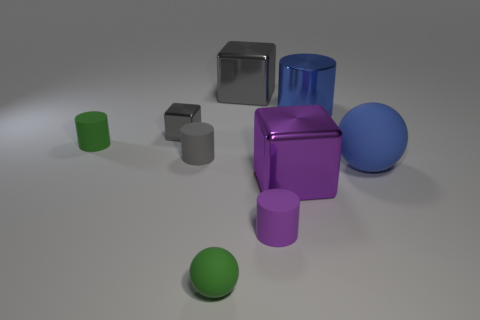Subtract all large blocks. How many blocks are left? 1 Subtract all gray cylinders. How many cylinders are left? 3 Subtract all cubes. How many objects are left? 6 Add 8 tiny green matte balls. How many tiny green matte balls are left? 9 Add 6 tiny purple cylinders. How many tiny purple cylinders exist? 7 Subtract 1 gray cylinders. How many objects are left? 8 Subtract 2 cylinders. How many cylinders are left? 2 Subtract all yellow spheres. Subtract all blue cylinders. How many spheres are left? 2 Subtract all red balls. How many gray cubes are left? 2 Subtract all gray cylinders. Subtract all big purple things. How many objects are left? 7 